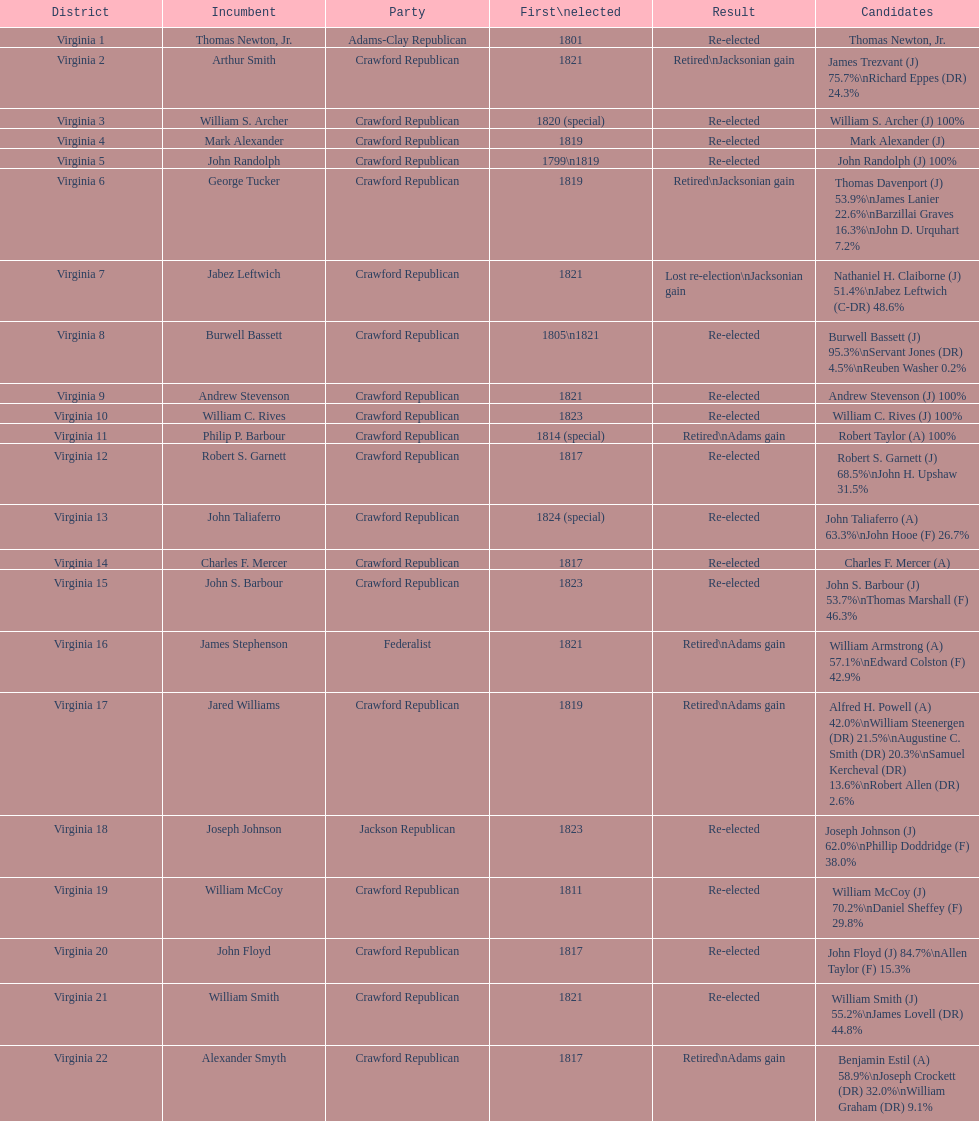What are the number of times re-elected is listed as the result? 15. 